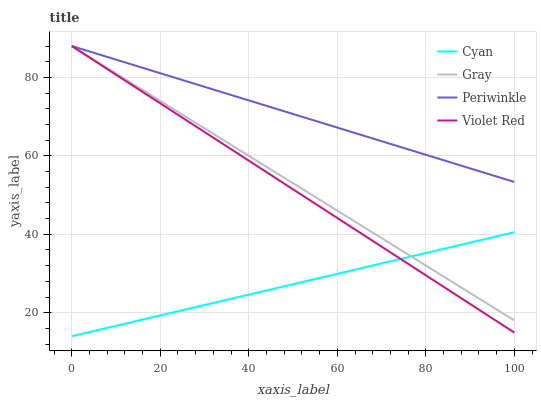Does Violet Red have the minimum area under the curve?
Answer yes or no. No. Does Violet Red have the maximum area under the curve?
Answer yes or no. No. Is Periwinkle the smoothest?
Answer yes or no. No. Is Violet Red the roughest?
Answer yes or no. No. Does Violet Red have the lowest value?
Answer yes or no. No. Is Cyan less than Periwinkle?
Answer yes or no. Yes. Is Periwinkle greater than Cyan?
Answer yes or no. Yes. Does Cyan intersect Periwinkle?
Answer yes or no. No. 